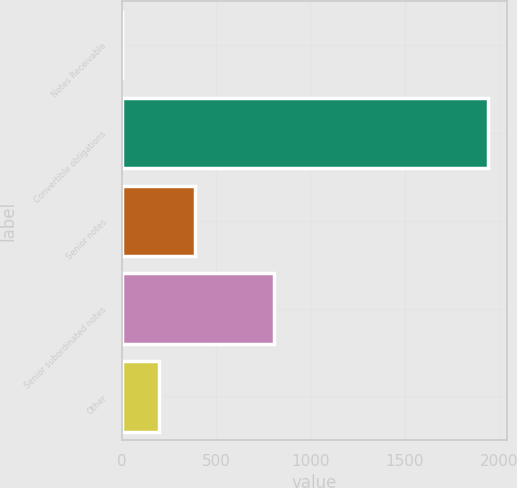<chart> <loc_0><loc_0><loc_500><loc_500><bar_chart><fcel>Notes Receivable<fcel>Convertible obligations<fcel>Senior notes<fcel>Senior subordinated notes<fcel>Other<nl><fcel>2.6<fcel>1944.3<fcel>390.94<fcel>806.6<fcel>196.77<nl></chart> 